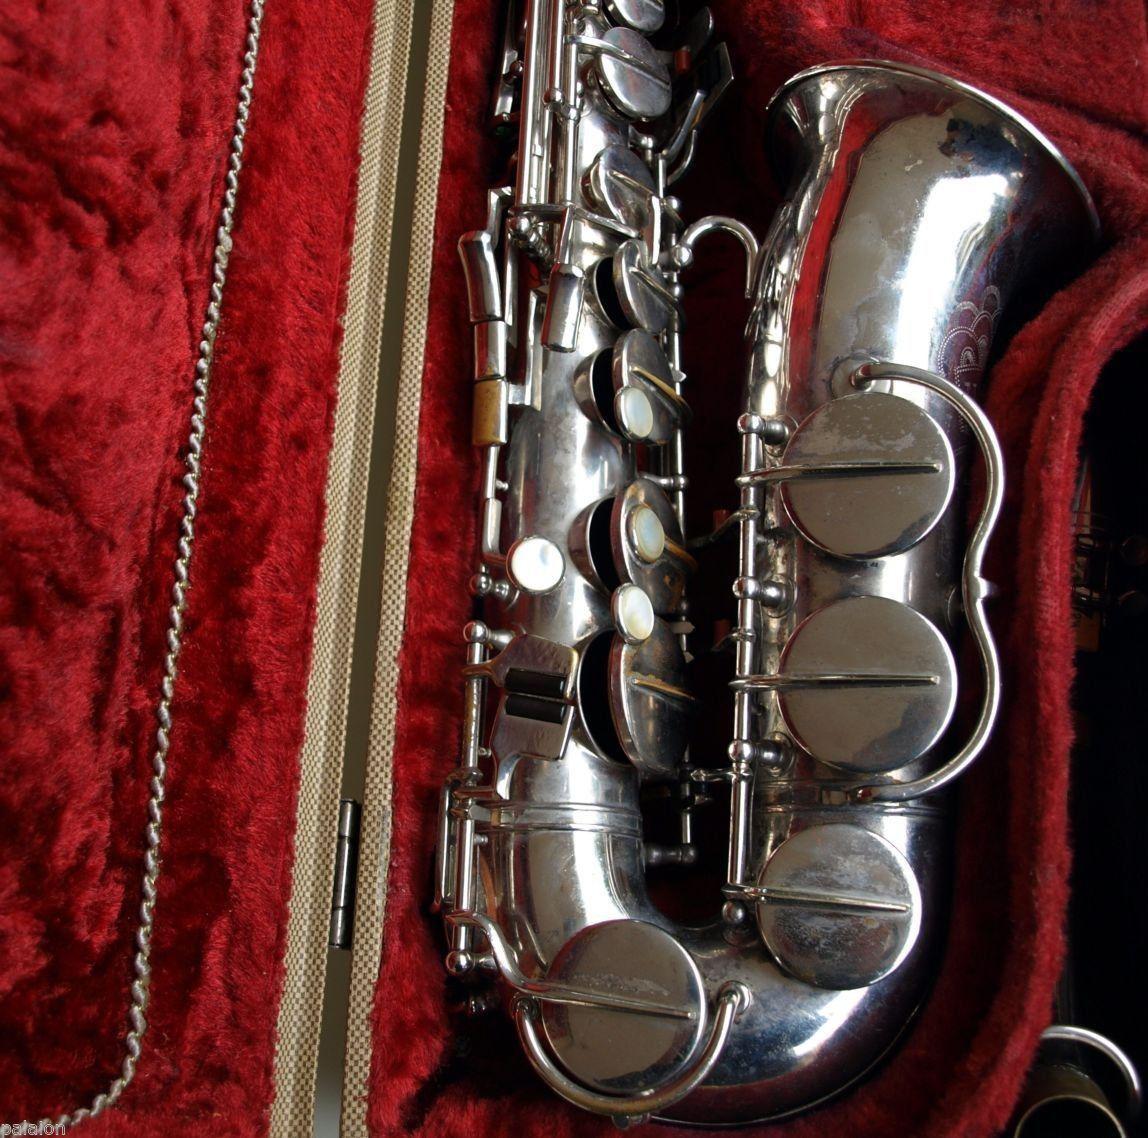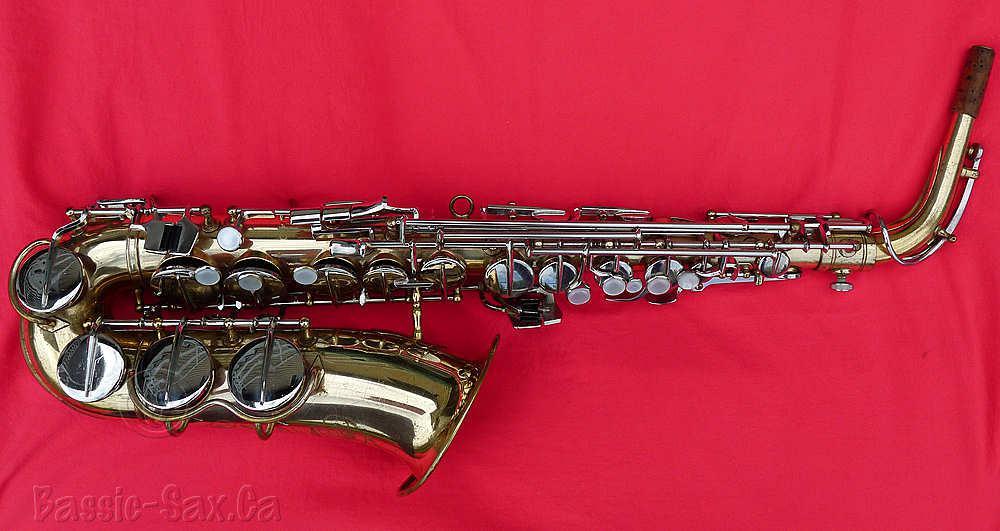The first image is the image on the left, the second image is the image on the right. Examine the images to the left and right. Is the description "In one image, a full length saxophone is lying flat on a cloth, while a second image shows only the lower section of a silver saxophone." accurate? Answer yes or no. Yes. The first image is the image on the left, the second image is the image on the right. Given the left and right images, does the statement "An image shows a silver saxophone in an open case lined with crushed red velvet." hold true? Answer yes or no. Yes. 